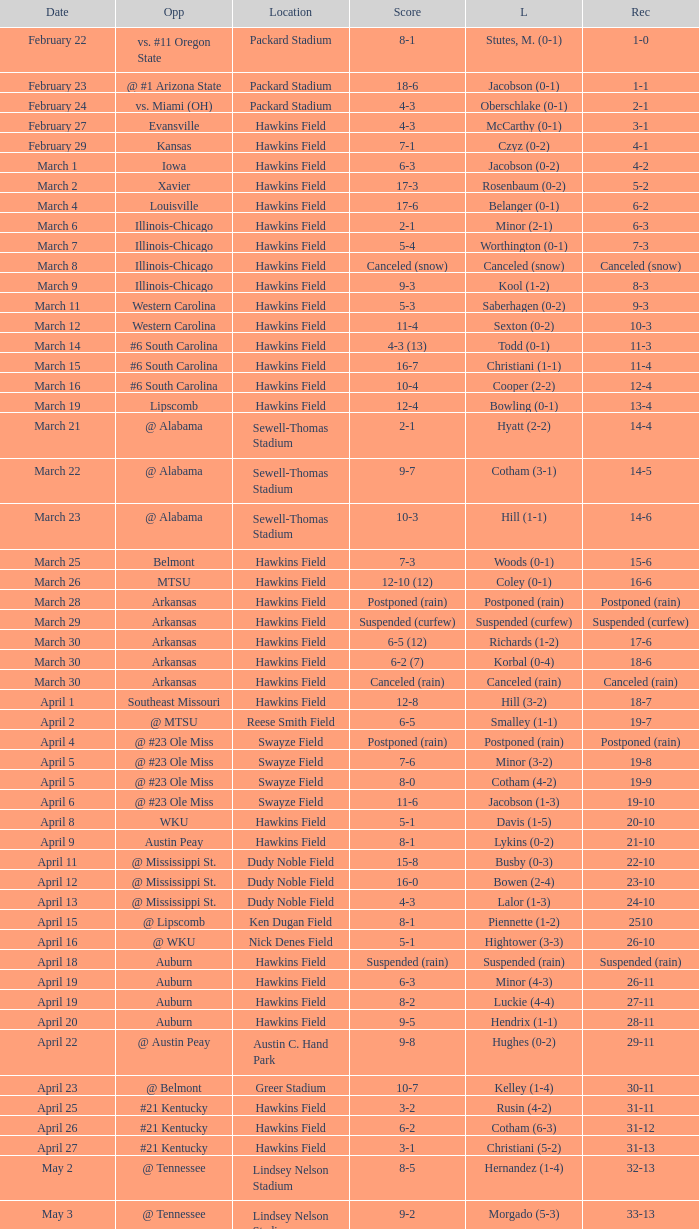What was the location of the game when the record was 12-4? Hawkins Field. 